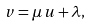Convert formula to latex. <formula><loc_0><loc_0><loc_500><loc_500>v = \mu \, u + \lambda ,</formula> 